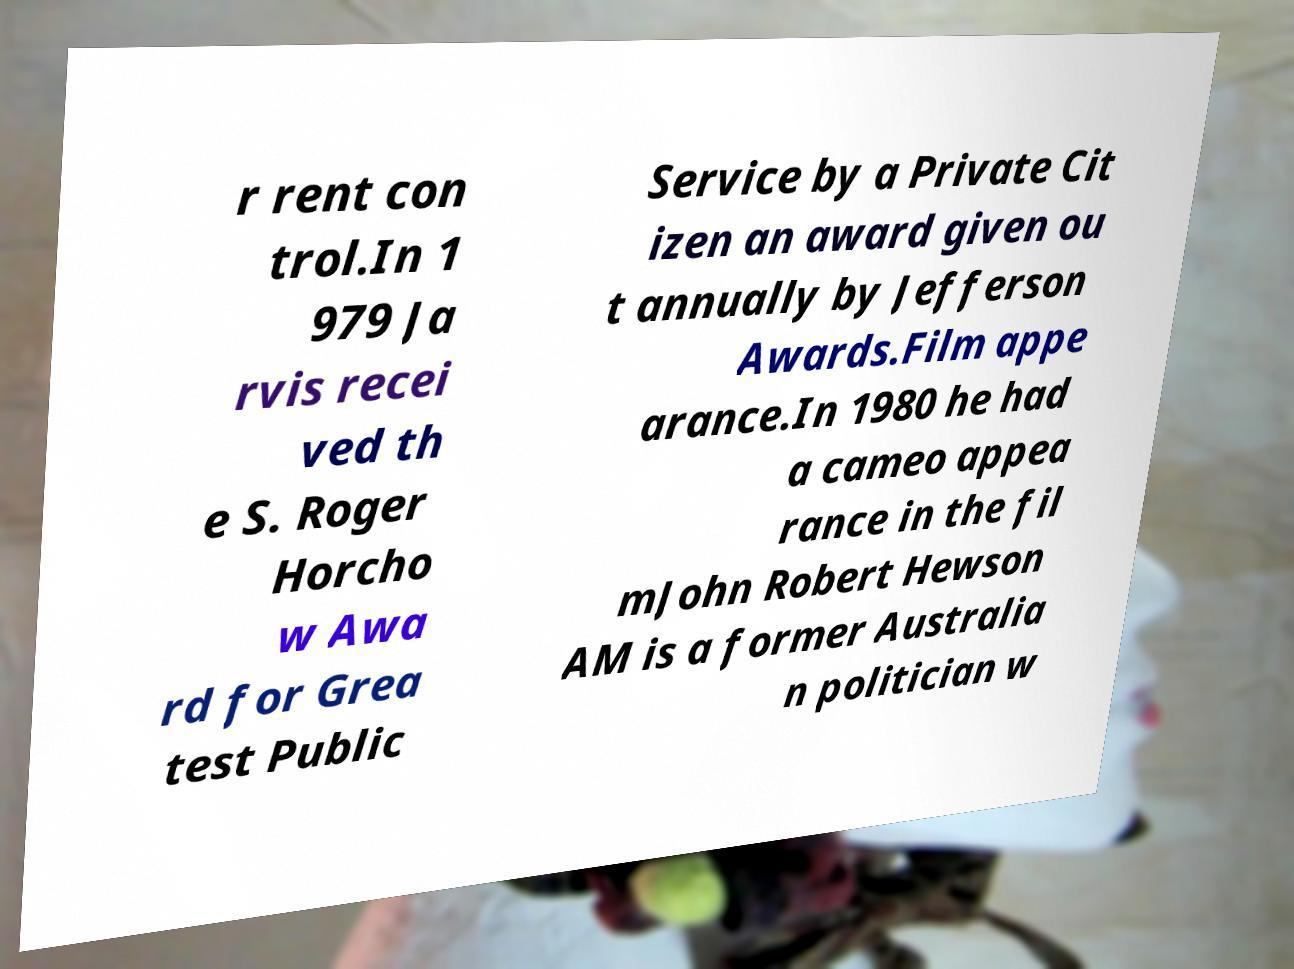What messages or text are displayed in this image? I need them in a readable, typed format. r rent con trol.In 1 979 Ja rvis recei ved th e S. Roger Horcho w Awa rd for Grea test Public Service by a Private Cit izen an award given ou t annually by Jefferson Awards.Film appe arance.In 1980 he had a cameo appea rance in the fil mJohn Robert Hewson AM is a former Australia n politician w 